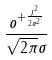<formula> <loc_0><loc_0><loc_500><loc_500>\frac { o ^ { + \frac { j ^ { 2 } } { 2 \sigma ^ { 2 } } } } { \sqrt { 2 \pi } \sigma }</formula> 